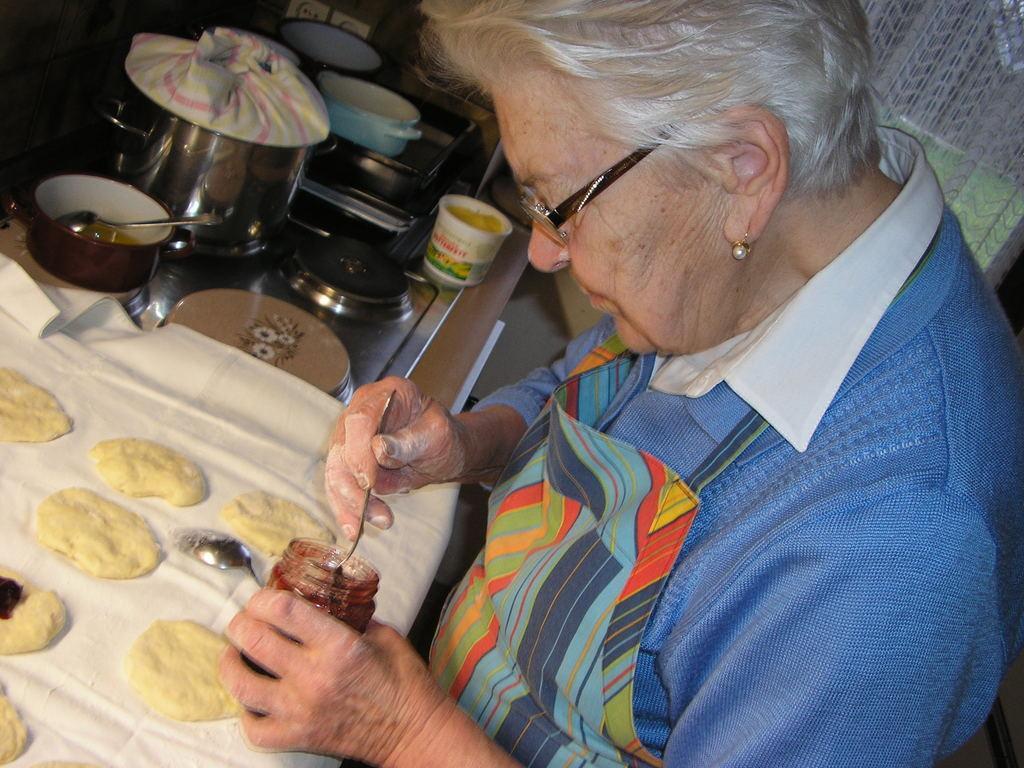How would you summarize this image in a sentence or two? In this picture we can see a woman standing and holding a bottle and a spoon, we can see a cloth in front of her, there are some bowls and a cup here, we can see two spoons here. 